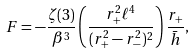<formula> <loc_0><loc_0><loc_500><loc_500>F = - \frac { \zeta ( 3 ) } { \beta ^ { 3 } } \left ( \frac { r _ { + } ^ { 2 } \ell ^ { 4 } } { ( r _ { + } ^ { 2 } - r _ { - } ^ { 2 } ) ^ { 2 } } \right ) \frac { r _ { + } } { \bar { h } } ,</formula> 